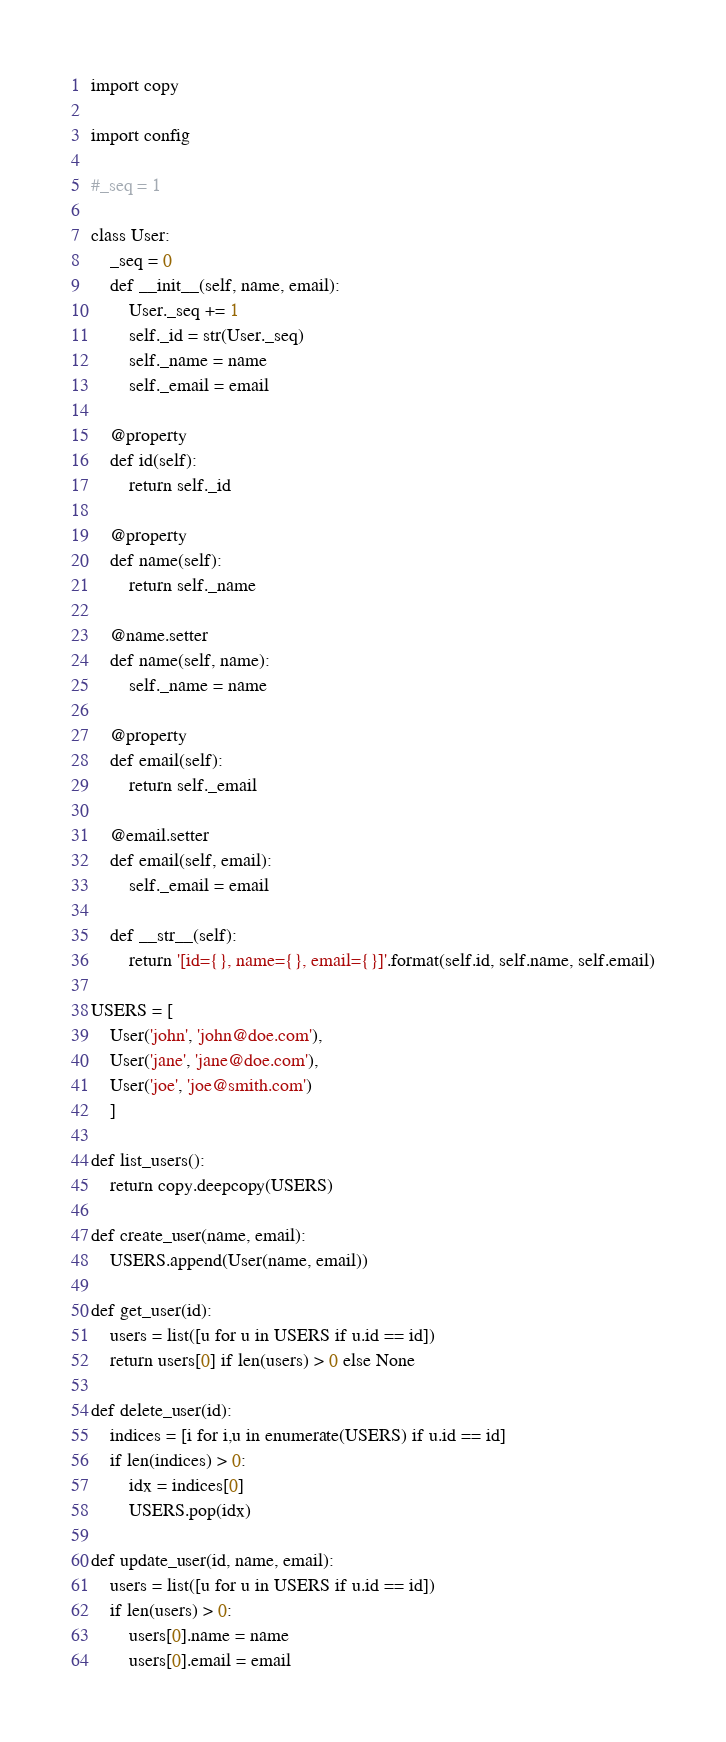Convert code to text. <code><loc_0><loc_0><loc_500><loc_500><_Python_>
import copy

import config

#_seq = 1

class User:
    _seq = 0
    def __init__(self, name, email):
        User._seq += 1
        self._id = str(User._seq)
        self._name = name
        self._email = email

    @property
    def id(self):
        return self._id

    @property
    def name(self):
        return self._name

    @name.setter
    def name(self, name):
        self._name = name

    @property
    def email(self):
        return self._email

    @email.setter
    def email(self, email):
        self._email = email

    def __str__(self):
        return '[id={}, name={}, email={}]'.format(self.id, self.name, self.email)

USERS = [
    User('john', 'john@doe.com'),
    User('jane', 'jane@doe.com'),
    User('joe', 'joe@smith.com')
    ]

def list_users():
    return copy.deepcopy(USERS)

def create_user(name, email):
    USERS.append(User(name, email))

def get_user(id):
    users = list([u for u in USERS if u.id == id])
    return users[0] if len(users) > 0 else None

def delete_user(id):
    indices = [i for i,u in enumerate(USERS) if u.id == id]
    if len(indices) > 0:
        idx = indices[0]
        USERS.pop(idx)

def update_user(id, name, email):
    users = list([u for u in USERS if u.id == id])
    if len(users) > 0:
        users[0].name = name
        users[0].email = email




</code> 